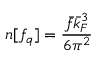<formula> <loc_0><loc_0><loc_500><loc_500>n [ f _ { q } ] = \frac { \bar { f } \bar { k } _ { F } ^ { 3 } } { 6 \pi ^ { 2 } }</formula> 